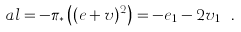<formula> <loc_0><loc_0><loc_500><loc_500>\ a l = - \pi _ { * } \left ( ( e + v ) ^ { 2 } \right ) = - e _ { 1 } - 2 v _ { 1 } \ .</formula> 